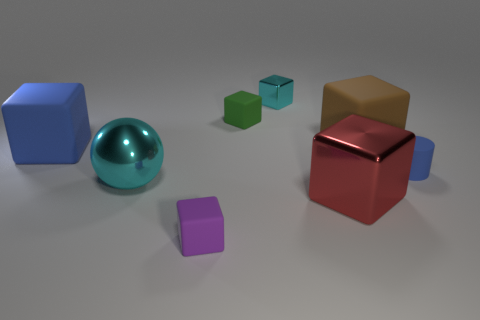Subtract all blue cubes. How many cubes are left? 5 Subtract all tiny green rubber blocks. How many blocks are left? 5 Add 1 tiny green rubber objects. How many objects exist? 9 Subtract all yellow blocks. Subtract all yellow spheres. How many blocks are left? 6 Subtract all blocks. How many objects are left? 2 Add 4 big blue shiny spheres. How many big blue shiny spheres exist? 4 Subtract 0 green cylinders. How many objects are left? 8 Subtract all blue cubes. Subtract all red shiny cubes. How many objects are left? 6 Add 3 large red things. How many large red things are left? 4 